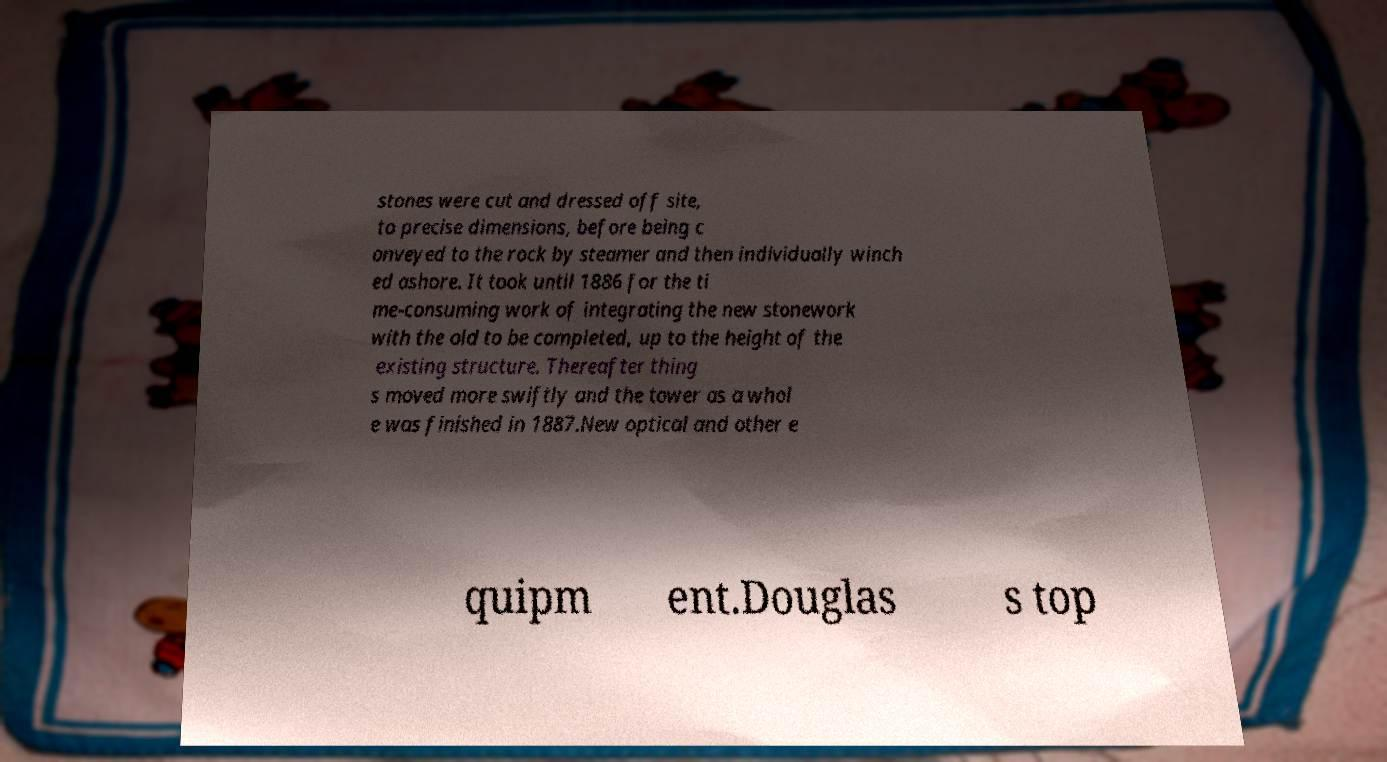I need the written content from this picture converted into text. Can you do that? stones were cut and dressed off site, to precise dimensions, before being c onveyed to the rock by steamer and then individually winch ed ashore. It took until 1886 for the ti me-consuming work of integrating the new stonework with the old to be completed, up to the height of the existing structure. Thereafter thing s moved more swiftly and the tower as a whol e was finished in 1887.New optical and other e quipm ent.Douglas s top 